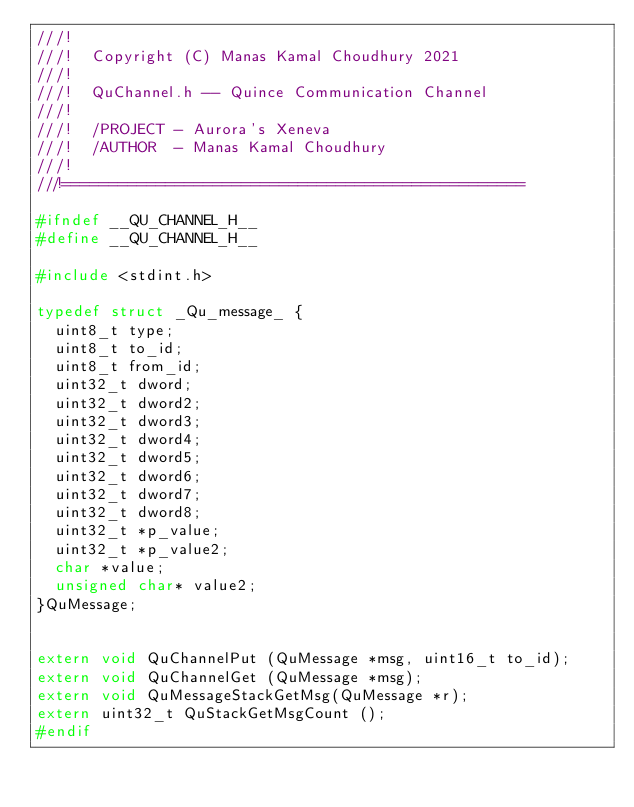<code> <loc_0><loc_0><loc_500><loc_500><_C_>///!
///!  Copyright (C) Manas Kamal Choudhury 2021
///!
///!  QuChannel.h -- Quince Communication Channel
///!
///!  /PROJECT - Aurora's Xeneva
///!  /AUTHOR  - Manas Kamal Choudhury
///!
///!=================================================

#ifndef __QU_CHANNEL_H__
#define __QU_CHANNEL_H__

#include <stdint.h>

typedef struct _Qu_message_ {
	uint8_t type;
	uint8_t to_id;
	uint8_t from_id;
	uint32_t dword;
	uint32_t dword2;
	uint32_t dword3;
	uint32_t dword4;
	uint32_t dword5;
	uint32_t dword6;
	uint32_t dword7;
	uint32_t dword8;
	uint32_t *p_value;
	uint32_t *p_value2;
	char *value;
	unsigned char* value2;
}QuMessage;


extern void QuChannelPut (QuMessage *msg, uint16_t to_id);
extern void QuChannelGet (QuMessage *msg);
extern void QuMessageStackGetMsg(QuMessage *r);
extern uint32_t QuStackGetMsgCount ();
#endif</code> 